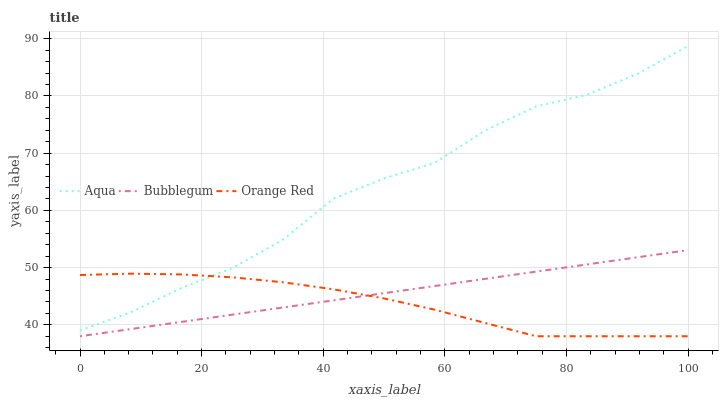Does Orange Red have the minimum area under the curve?
Answer yes or no. Yes. Does Aqua have the maximum area under the curve?
Answer yes or no. Yes. Does Bubblegum have the minimum area under the curve?
Answer yes or no. No. Does Bubblegum have the maximum area under the curve?
Answer yes or no. No. Is Bubblegum the smoothest?
Answer yes or no. Yes. Is Aqua the roughest?
Answer yes or no. Yes. Is Orange Red the smoothest?
Answer yes or no. No. Is Orange Red the roughest?
Answer yes or no. No. Does Orange Red have the lowest value?
Answer yes or no. Yes. Does Aqua have the highest value?
Answer yes or no. Yes. Does Bubblegum have the highest value?
Answer yes or no. No. Is Bubblegum less than Aqua?
Answer yes or no. Yes. Is Aqua greater than Bubblegum?
Answer yes or no. Yes. Does Orange Red intersect Aqua?
Answer yes or no. Yes. Is Orange Red less than Aqua?
Answer yes or no. No. Is Orange Red greater than Aqua?
Answer yes or no. No. Does Bubblegum intersect Aqua?
Answer yes or no. No. 